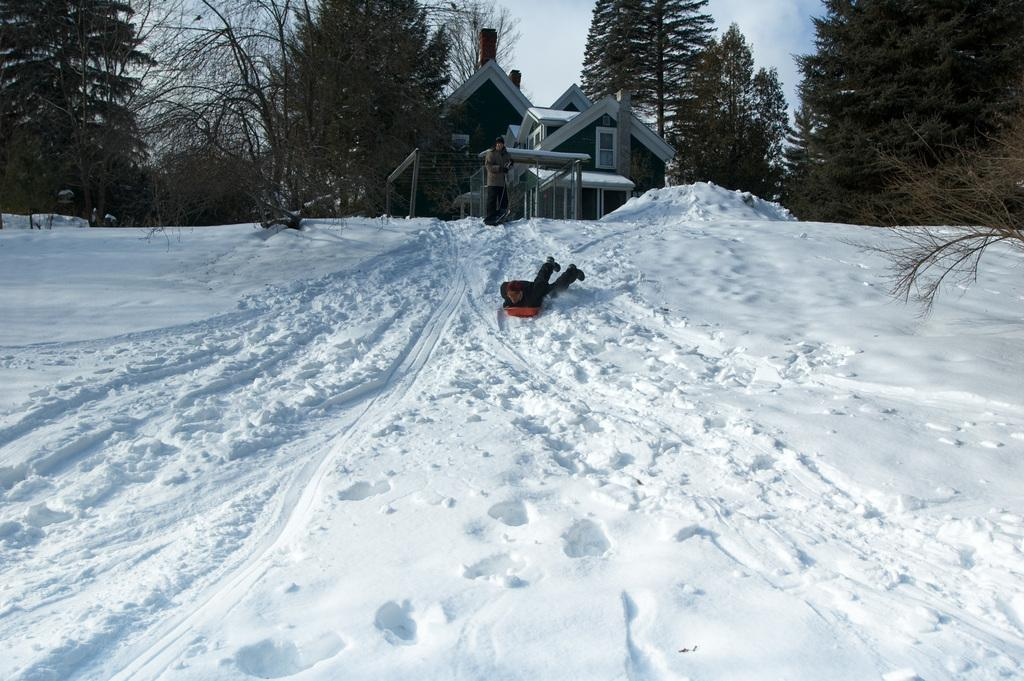What is the person in the image doing? The person is lying on a board and skating on the snow. Can you describe the background of the image? The background includes a house, windows, trees, and the sky. Are there any other people visible in the image? Yes, there is a person standing in the background of the image. What type of steam can be seen coming from the person's skates in the image? There is no steam visible in the image; the person is skating on snow, not steam. 